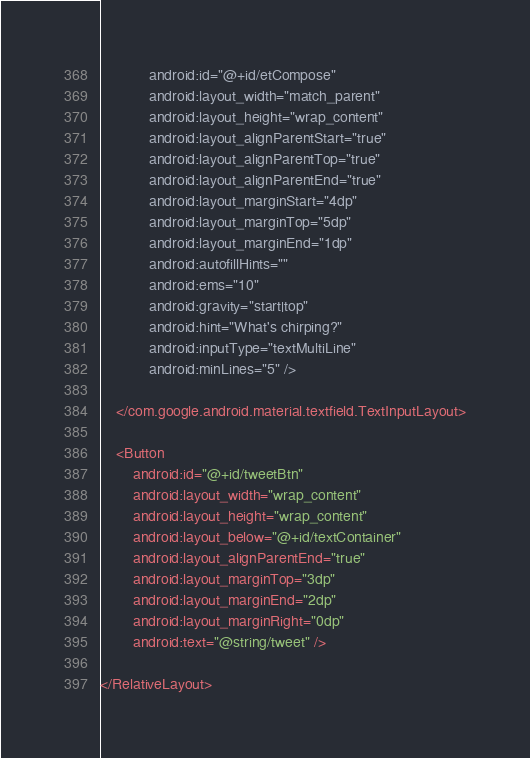Convert code to text. <code><loc_0><loc_0><loc_500><loc_500><_XML_>            android:id="@+id/etCompose"
            android:layout_width="match_parent"
            android:layout_height="wrap_content"
            android:layout_alignParentStart="true"
            android:layout_alignParentTop="true"
            android:layout_alignParentEnd="true"
            android:layout_marginStart="4dp"
            android:layout_marginTop="5dp"
            android:layout_marginEnd="1dp"
            android:autofillHints=""
            android:ems="10"
            android:gravity="start|top"
            android:hint="What's chirping?"
            android:inputType="textMultiLine"
            android:minLines="5" />

    </com.google.android.material.textfield.TextInputLayout>

    <Button
        android:id="@+id/tweetBtn"
        android:layout_width="wrap_content"
        android:layout_height="wrap_content"
        android:layout_below="@+id/textContainer"
        android:layout_alignParentEnd="true"
        android:layout_marginTop="3dp"
        android:layout_marginEnd="2dp"
        android:layout_marginRight="0dp"
        android:text="@string/tweet" />

</RelativeLayout></code> 